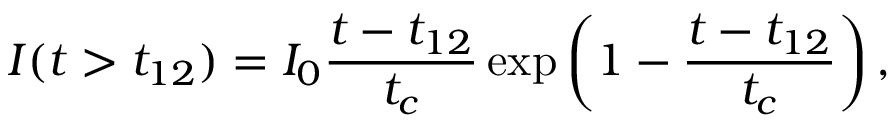Convert formula to latex. <formula><loc_0><loc_0><loc_500><loc_500>I ( t > t _ { 1 2 } ) = I _ { 0 } \frac { t - t _ { 1 2 } } { t _ { c } } \exp \left ( 1 - \frac { t - t _ { 1 2 } } { t _ { c } } \right ) ,</formula> 